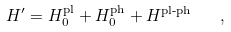Convert formula to latex. <formula><loc_0><loc_0><loc_500><loc_500>H ^ { \prime } = H ^ { \text {pl} } _ { 0 } + H ^ { \text {ph} } _ { 0 } + H ^ { \text {pl-ph} } \quad ,</formula> 